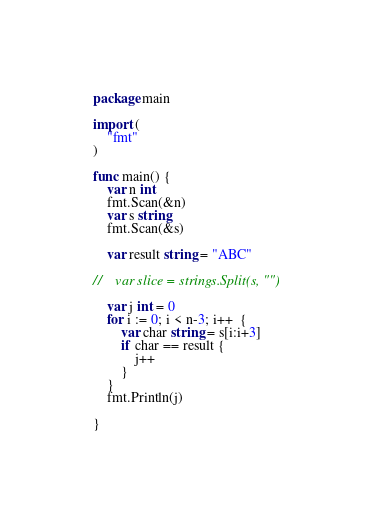Convert code to text. <code><loc_0><loc_0><loc_500><loc_500><_Go_>package main

import (
    "fmt"
)

func main() {
    var n int
    fmt.Scan(&n)
    var s string
    fmt.Scan(&s)

    var result string = "ABC"

//    var slice = strings.Split(s, "")

    var j int = 0
    for i := 0; i < n-3; i++  {
        var char string = s[i:i+3]
        if char == result {
            j++
        }
    }
    fmt.Println(j)

}

</code> 